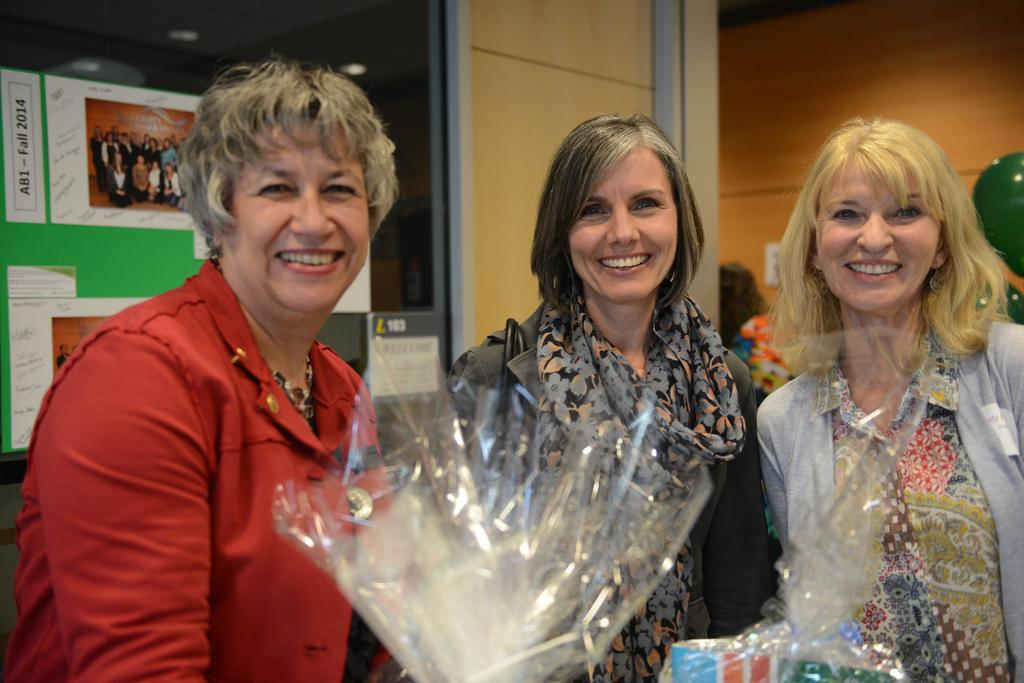How many women are in the image? There are three women in the image. What is the facial expression of the women? The women are smiling. What can be seen on the board in the image? There is text, numbers, images of people, and other objects visible on the board. What type of lighting is present in the image? There are lights visible in the image. Can you tell me how many hens are sitting on the board in the image? There are no hens present on the board or in the image. What type of afterthought is visible on the board in the image? There is no mention of an afterthought on the board or in the image. 